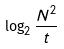<formula> <loc_0><loc_0><loc_500><loc_500>\log _ { 2 } \frac { N ^ { 2 } } { t }</formula> 